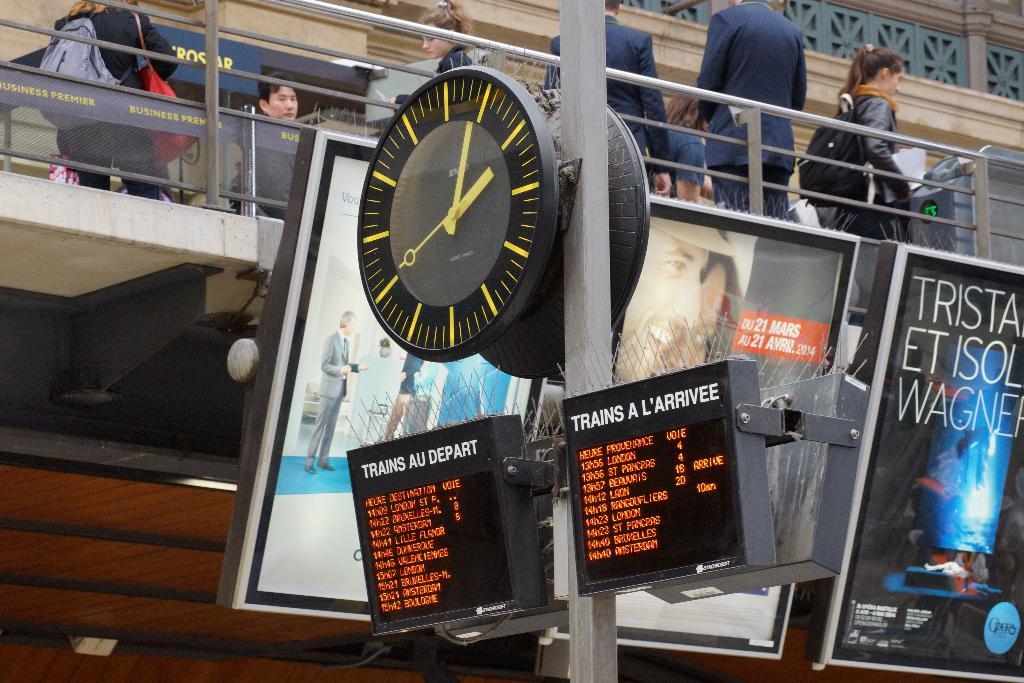When does the first train arrive?
Keep it short and to the point. Unanswerable. What time does the clock show?
Make the answer very short. 2:04. 